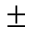Convert formula to latex. <formula><loc_0><loc_0><loc_500><loc_500>\pm</formula> 